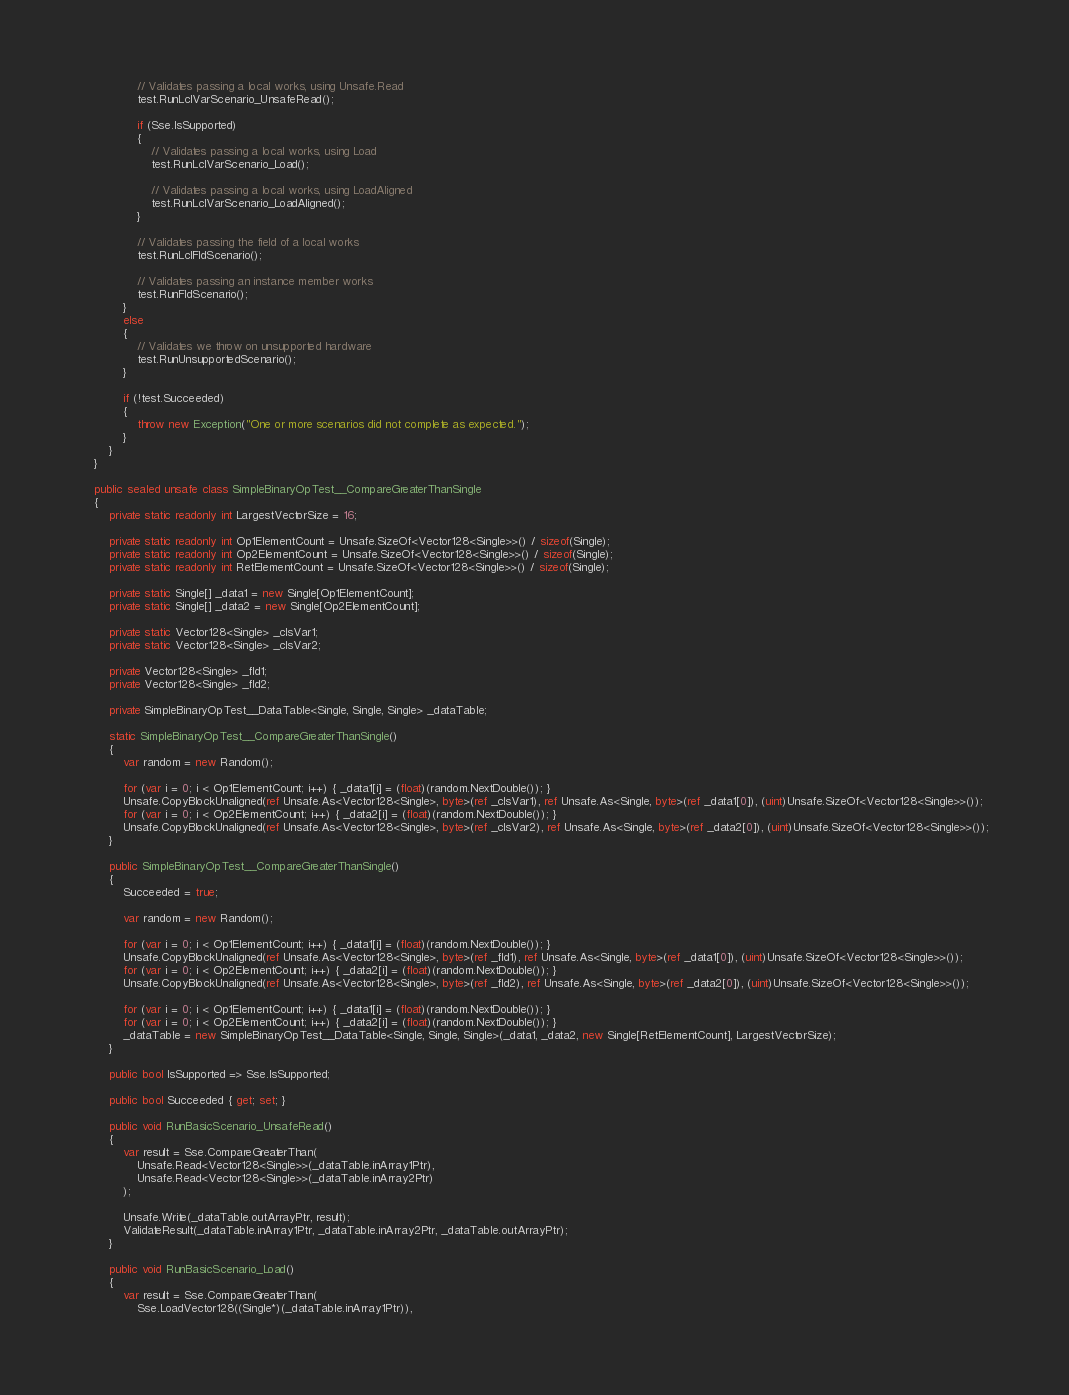<code> <loc_0><loc_0><loc_500><loc_500><_C#_>                // Validates passing a local works, using Unsafe.Read
                test.RunLclVarScenario_UnsafeRead();

                if (Sse.IsSupported)
                {
                    // Validates passing a local works, using Load
                    test.RunLclVarScenario_Load();

                    // Validates passing a local works, using LoadAligned
                    test.RunLclVarScenario_LoadAligned();
                }

                // Validates passing the field of a local works
                test.RunLclFldScenario();

                // Validates passing an instance member works
                test.RunFldScenario();
            }
            else
            {
                // Validates we throw on unsupported hardware
                test.RunUnsupportedScenario();
            }

            if (!test.Succeeded)
            {
                throw new Exception("One or more scenarios did not complete as expected.");
            }
        }
    }

    public sealed unsafe class SimpleBinaryOpTest__CompareGreaterThanSingle
    {
        private static readonly int LargestVectorSize = 16;

        private static readonly int Op1ElementCount = Unsafe.SizeOf<Vector128<Single>>() / sizeof(Single);
        private static readonly int Op2ElementCount = Unsafe.SizeOf<Vector128<Single>>() / sizeof(Single);
        private static readonly int RetElementCount = Unsafe.SizeOf<Vector128<Single>>() / sizeof(Single);

        private static Single[] _data1 = new Single[Op1ElementCount];
        private static Single[] _data2 = new Single[Op2ElementCount];

        private static Vector128<Single> _clsVar1;
        private static Vector128<Single> _clsVar2;

        private Vector128<Single> _fld1;
        private Vector128<Single> _fld2;

        private SimpleBinaryOpTest__DataTable<Single, Single, Single> _dataTable;

        static SimpleBinaryOpTest__CompareGreaterThanSingle()
        {
            var random = new Random();

            for (var i = 0; i < Op1ElementCount; i++) { _data1[i] = (float)(random.NextDouble()); }
            Unsafe.CopyBlockUnaligned(ref Unsafe.As<Vector128<Single>, byte>(ref _clsVar1), ref Unsafe.As<Single, byte>(ref _data1[0]), (uint)Unsafe.SizeOf<Vector128<Single>>());
            for (var i = 0; i < Op2ElementCount; i++) { _data2[i] = (float)(random.NextDouble()); }
            Unsafe.CopyBlockUnaligned(ref Unsafe.As<Vector128<Single>, byte>(ref _clsVar2), ref Unsafe.As<Single, byte>(ref _data2[0]), (uint)Unsafe.SizeOf<Vector128<Single>>());
        }

        public SimpleBinaryOpTest__CompareGreaterThanSingle()
        {
            Succeeded = true;

            var random = new Random();

            for (var i = 0; i < Op1ElementCount; i++) { _data1[i] = (float)(random.NextDouble()); }
            Unsafe.CopyBlockUnaligned(ref Unsafe.As<Vector128<Single>, byte>(ref _fld1), ref Unsafe.As<Single, byte>(ref _data1[0]), (uint)Unsafe.SizeOf<Vector128<Single>>());
            for (var i = 0; i < Op2ElementCount; i++) { _data2[i] = (float)(random.NextDouble()); }
            Unsafe.CopyBlockUnaligned(ref Unsafe.As<Vector128<Single>, byte>(ref _fld2), ref Unsafe.As<Single, byte>(ref _data2[0]), (uint)Unsafe.SizeOf<Vector128<Single>>());

            for (var i = 0; i < Op1ElementCount; i++) { _data1[i] = (float)(random.NextDouble()); }
            for (var i = 0; i < Op2ElementCount; i++) { _data2[i] = (float)(random.NextDouble()); }
            _dataTable = new SimpleBinaryOpTest__DataTable<Single, Single, Single>(_data1, _data2, new Single[RetElementCount], LargestVectorSize);
        }

        public bool IsSupported => Sse.IsSupported;

        public bool Succeeded { get; set; }

        public void RunBasicScenario_UnsafeRead()
        {
            var result = Sse.CompareGreaterThan(
                Unsafe.Read<Vector128<Single>>(_dataTable.inArray1Ptr),
                Unsafe.Read<Vector128<Single>>(_dataTable.inArray2Ptr)
            );

            Unsafe.Write(_dataTable.outArrayPtr, result);
            ValidateResult(_dataTable.inArray1Ptr, _dataTable.inArray2Ptr, _dataTable.outArrayPtr);
        }

        public void RunBasicScenario_Load()
        {
            var result = Sse.CompareGreaterThan(
                Sse.LoadVector128((Single*)(_dataTable.inArray1Ptr)),</code> 